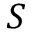Convert formula to latex. <formula><loc_0><loc_0><loc_500><loc_500>S</formula> 